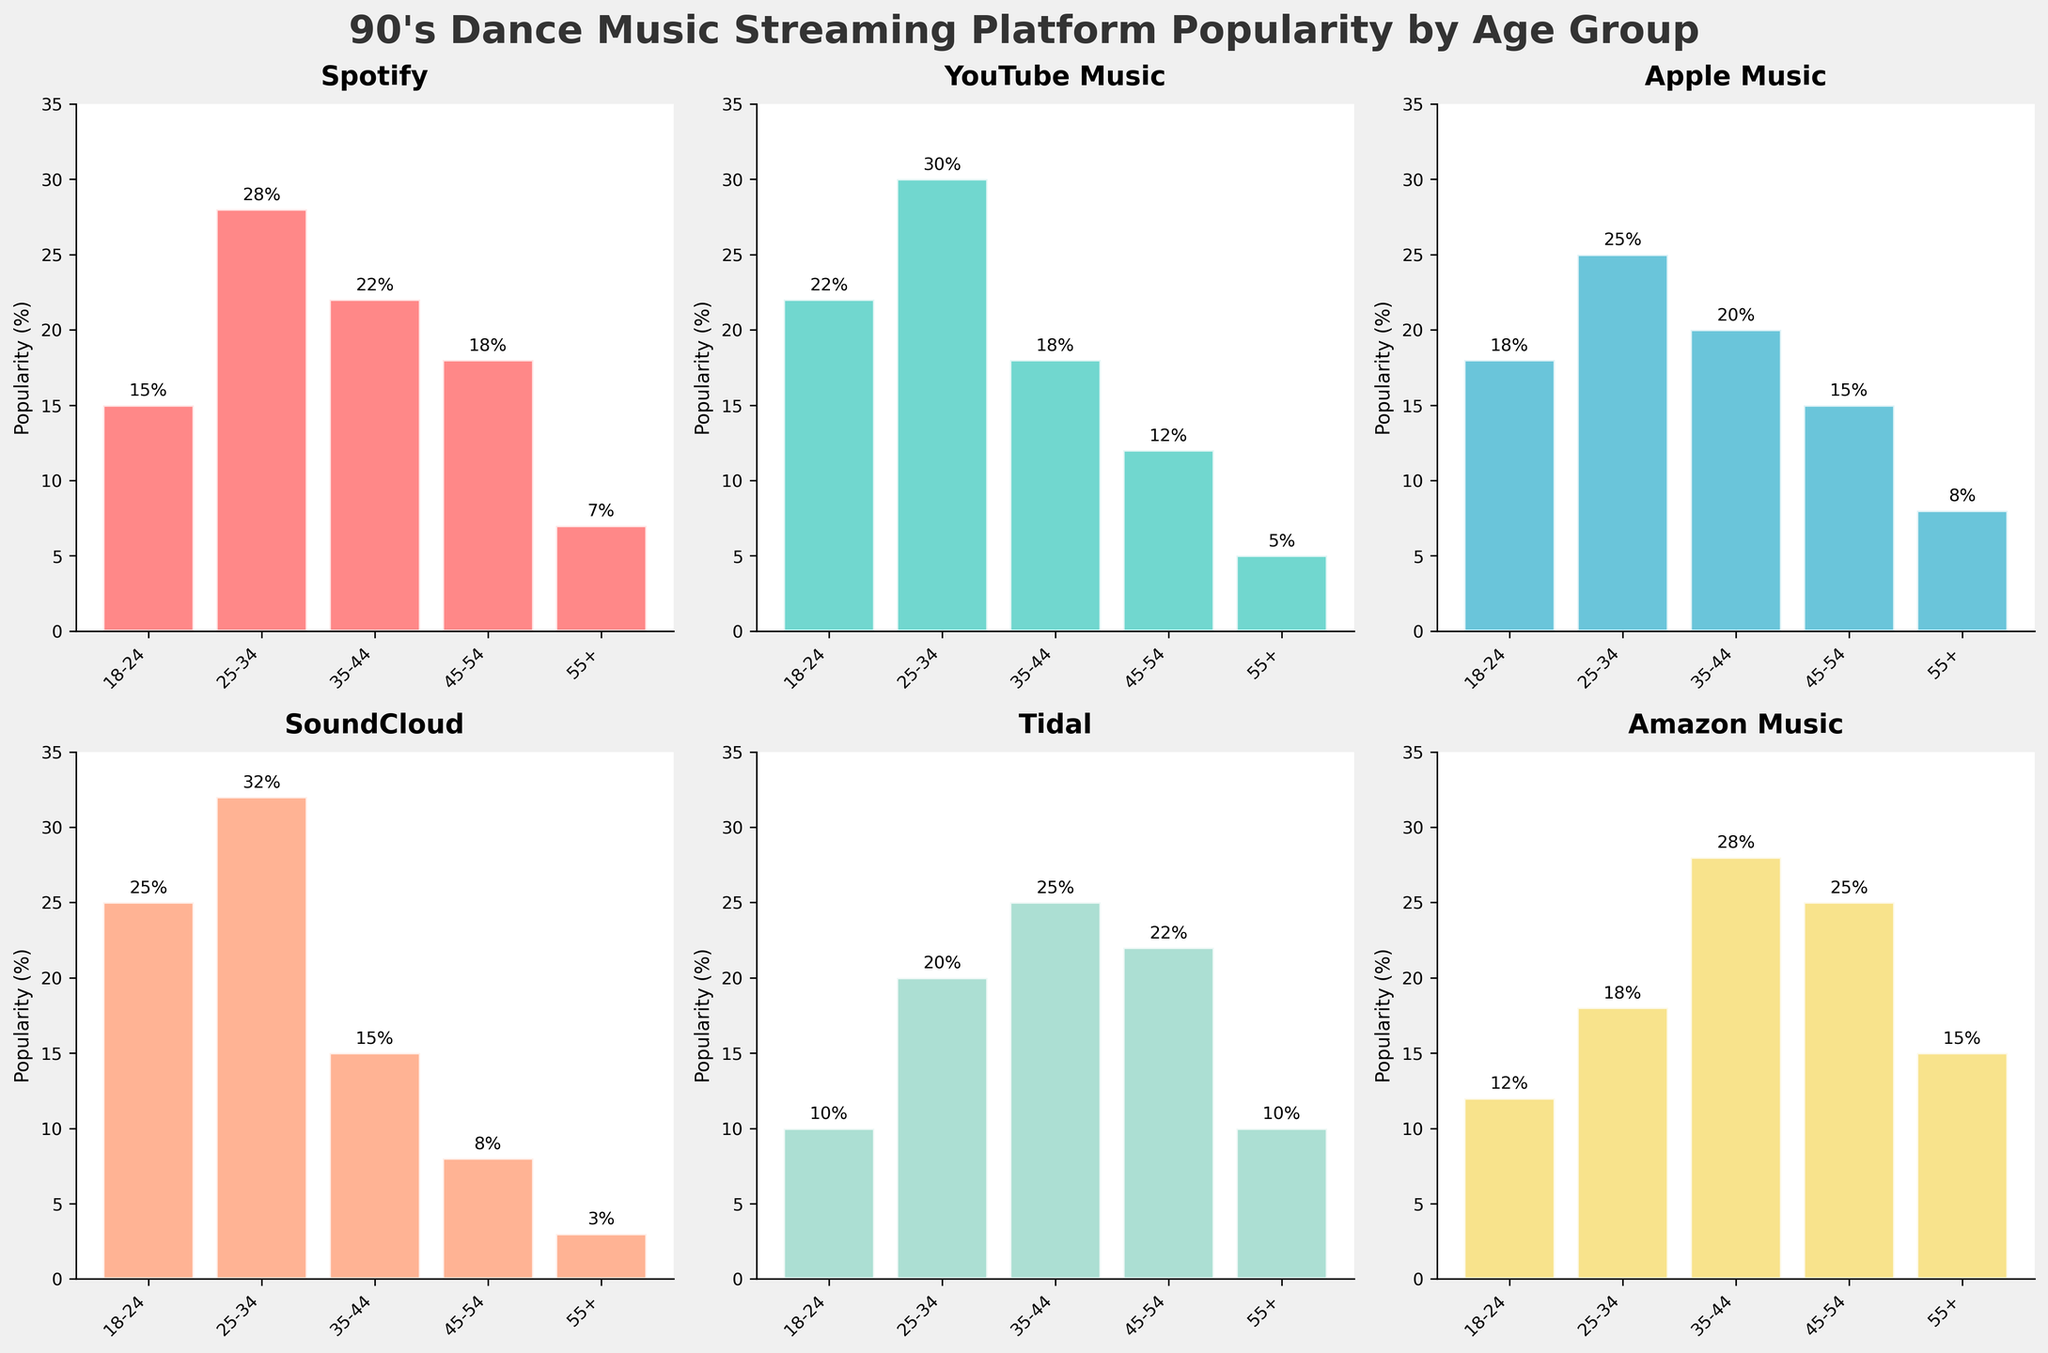What's the title of the figure? The title of the figure is displayed at the top and is usually the most prominent text.
Answer: 90's Dance Music Streaming Platform Popularity by Age Group Which streaming platform is most popular among the 18-24 age group? Look at the height of the bars for the 18-24 age group and find the tallest bar.
Answer: SoundCloud What is the average popularity of Apple Music among all age groups? Add up the percentages for Apple Music (18 + 25 + 20 + 15 + 8) and divide by the number of age groups (5). The calculation is (18+25+20+15+8)/5 = 17.2.
Answer: 17.2% Which platform has the smallest popularity gap between the 18-24 and 55+ age groups? Calculate the difference in popularity percentages between the 18-24 and 55+ groups for each platform and find the smallest difference: Spotify (15-7=8), YouTube Music (22-5=17), Apple Music (18-8=10), SoundCloud (25-3=22), Tidal (10-10=0), Amazon Music (12-15=3).
Answer: Tidal Is Spotify more popular among the 35-44 age group than Apple Music among the same group? Compare the heights of the bars representing the 35-44 age group for Spotify and Apple Music.
Answer: Yes Which platform shows the highest popularity among the 45-54 age group? Compare the heights of the bars representing the 45-54 age group across all platforms.
Answer: Amazon Music What is the combined popularity percentage for Amazon Music among the 45-54 and 55+ age groups? Add up the percentages for Amazon Music in the 45-54 (25) and 55+ (15) age groups: 25+15.
Answer: 40% How does the popularity of SoundCloud among the 25-34 age group compare to YouTube Music among the same group? Compare the heights of the bars for SoundCloud and YouTube Music in the 25-34 age group.
Answer: SoundCloud is more popular Is the 25-34 age group the most popular age group for all platforms? Check the bar heights for the 25-34 age group across all the platforms.
Answer: No 